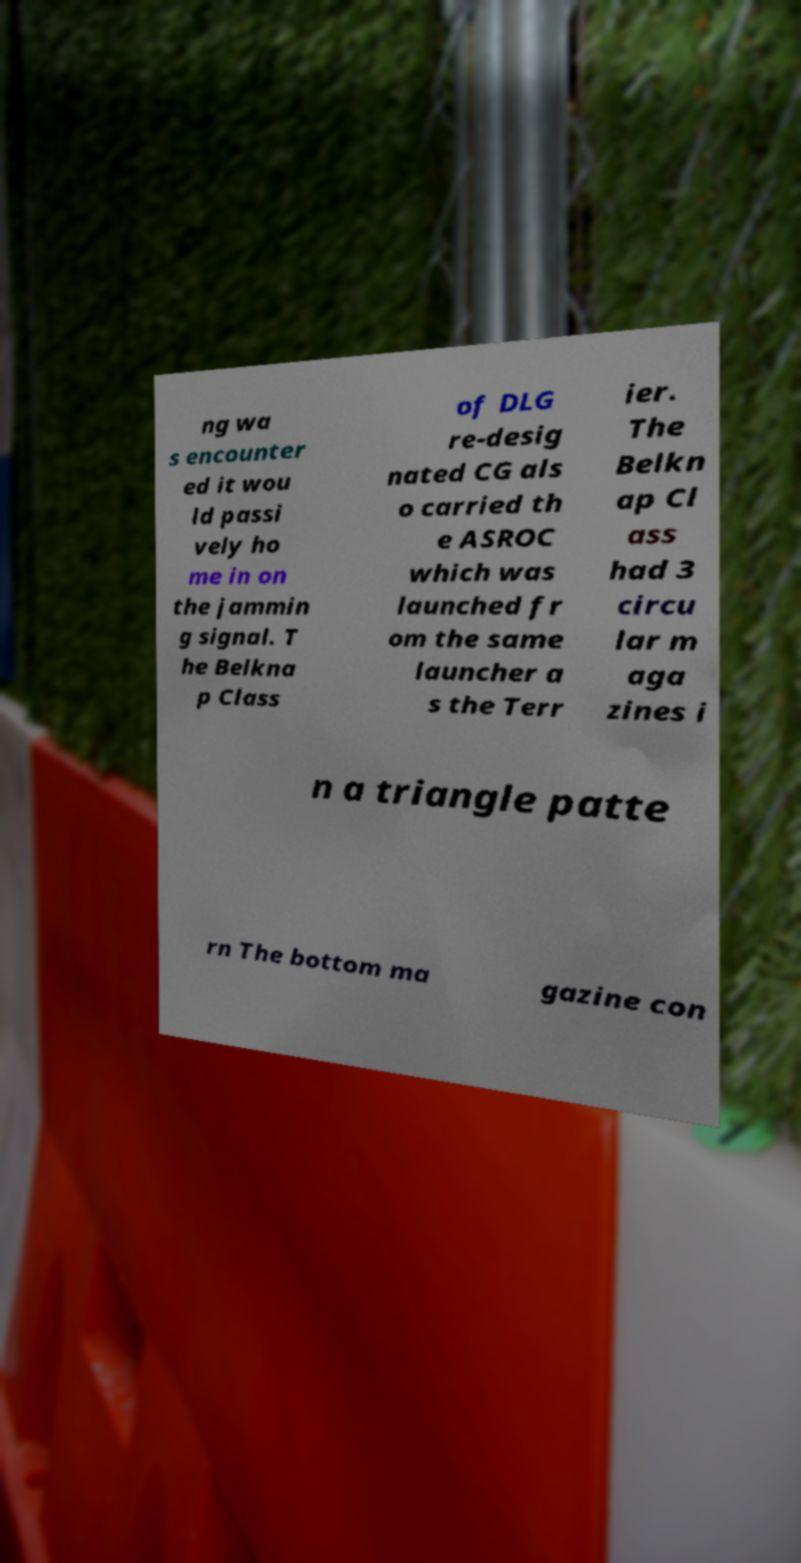Can you accurately transcribe the text from the provided image for me? ng wa s encounter ed it wou ld passi vely ho me in on the jammin g signal. T he Belkna p Class of DLG re-desig nated CG als o carried th e ASROC which was launched fr om the same launcher a s the Terr ier. The Belkn ap Cl ass had 3 circu lar m aga zines i n a triangle patte rn The bottom ma gazine con 